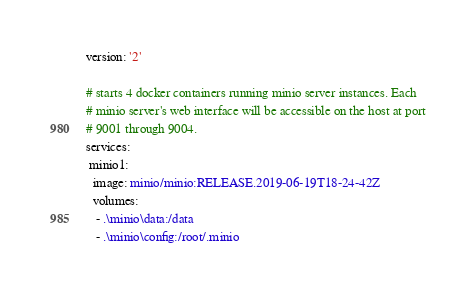Convert code to text. <code><loc_0><loc_0><loc_500><loc_500><_YAML_>version: '2'

# starts 4 docker containers running minio server instances. Each
# minio server's web interface will be accessible on the host at port
# 9001 through 9004.
services:
 minio1:
  image: minio/minio:RELEASE.2019-06-19T18-24-42Z
  volumes:
   - .\minio\data:/data 
   - .\minio\config:/root/.minio</code> 